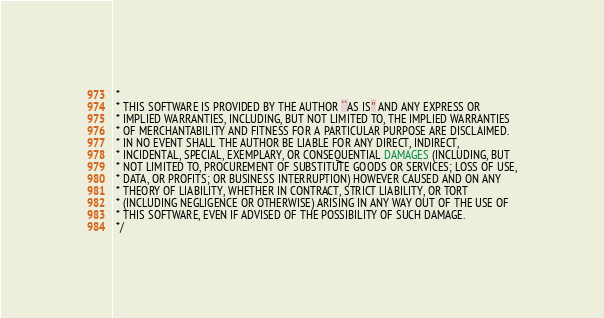Convert code to text. <code><loc_0><loc_0><loc_500><loc_500><_Java_> *
 * THIS SOFTWARE IS PROVIDED BY THE AUTHOR ``AS IS'' AND ANY EXPRESS OR
 * IMPLIED WARRANTIES, INCLUDING, BUT NOT LIMITED TO, THE IMPLIED WARRANTIES
 * OF MERCHANTABILITY AND FITNESS FOR A PARTICULAR PURPOSE ARE DISCLAIMED.
 * IN NO EVENT SHALL THE AUTHOR BE LIABLE FOR ANY DIRECT, INDIRECT,
 * INCIDENTAL, SPECIAL, EXEMPLARY, OR CONSEQUENTIAL DAMAGES (INCLUDING, BUT
 * NOT LIMITED TO, PROCUREMENT OF SUBSTITUTE GOODS OR SERVICES; LOSS OF USE,
 * DATA, OR PROFITS; OR BUSINESS INTERRUPTION) HOWEVER CAUSED AND ON ANY
 * THEORY OF LIABILITY, WHETHER IN CONTRACT, STRICT LIABILITY, OR TORT
 * (INCLUDING NEGLIGENCE OR OTHERWISE) ARISING IN ANY WAY OUT OF THE USE OF
 * THIS SOFTWARE, EVEN IF ADVISED OF THE POSSIBILITY OF SUCH DAMAGE.
 */</code> 